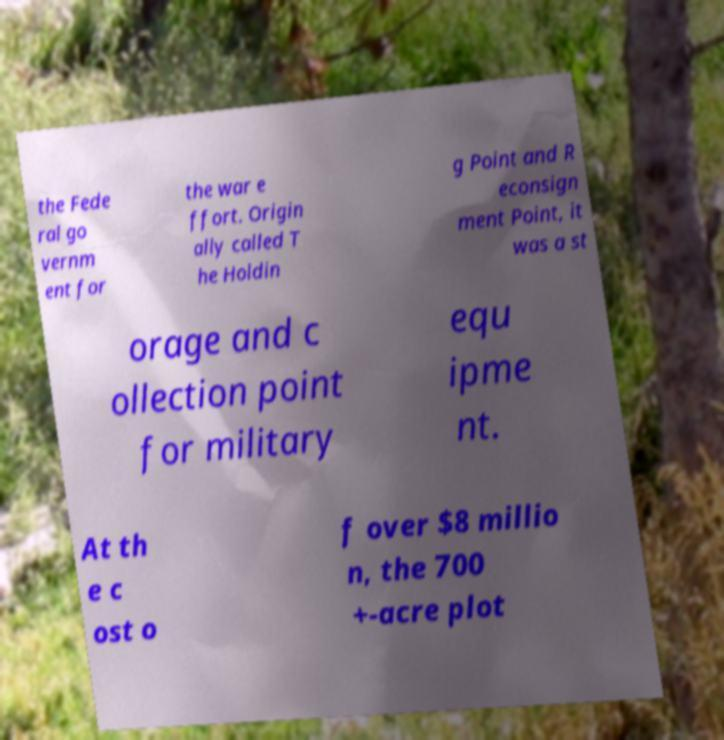There's text embedded in this image that I need extracted. Can you transcribe it verbatim? the Fede ral go vernm ent for the war e ffort. Origin ally called T he Holdin g Point and R econsign ment Point, it was a st orage and c ollection point for military equ ipme nt. At th e c ost o f over $8 millio n, the 700 +-acre plot 